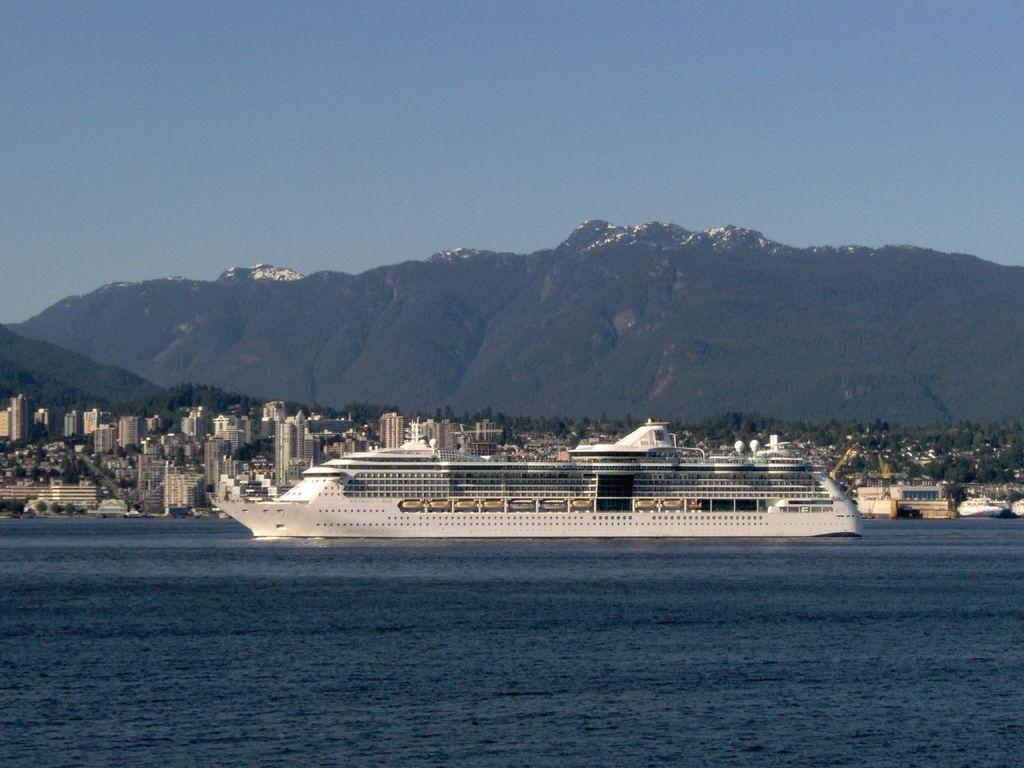What is the main subject of the image? The main subject of the image is a ship. Can you describe the ship's position in relation to the water? The ship is above the water in the image. What can be seen in the background of the image? There are buildings, trees, hills, and the sky visible in the background of the image. Who is the creator of the plants visible in the image? There are no plants mentioned or visible in the image, so it is not possible to determine the creator of any plants. 